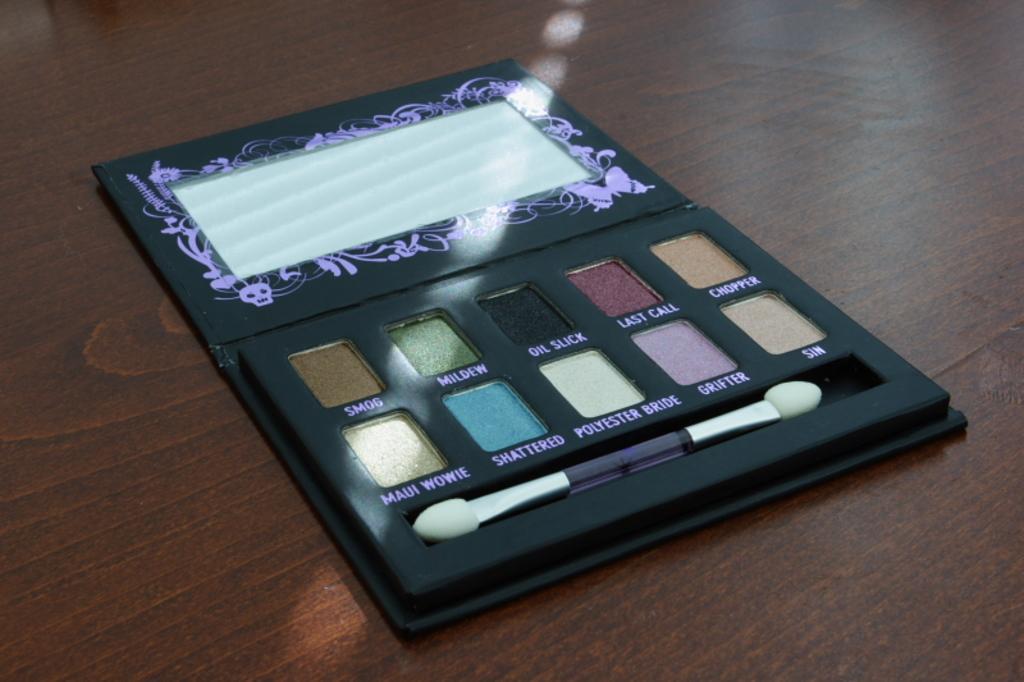In one or two sentences, can you explain what this image depicts? This image is taken indoors. At the bottom of the image there is a table with an eyeshadow palette on it. 